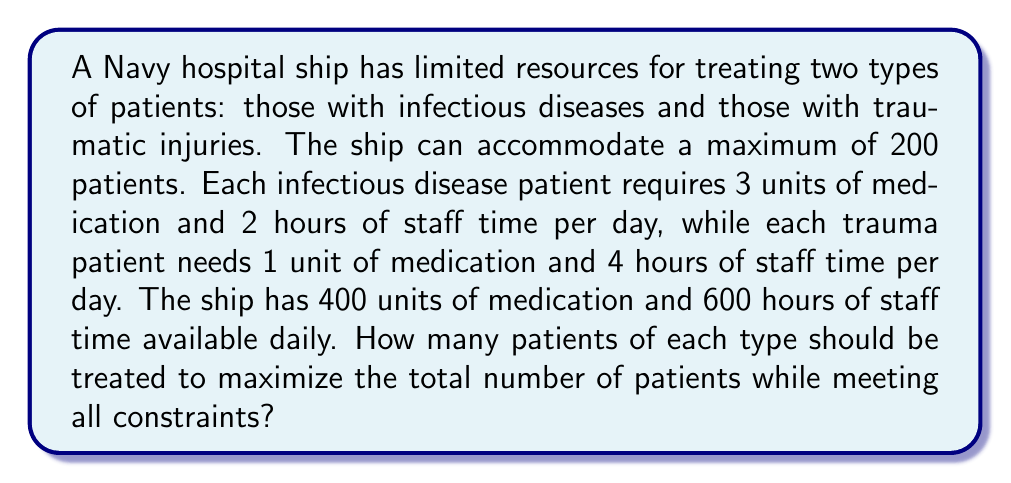Can you answer this question? Let's approach this step-by-step:

1) Define variables:
   Let $x$ = number of infectious disease patients
   Let $y$ = number of trauma patients

2) Set up the system of equations based on the constraints:

   Total patients: $x + y \leq 200$ (1)
   Medication constraint: $3x + y \leq 400$ (2)
   Staff time constraint: $2x + 4y \leq 600$ (3)

3) Our objective is to maximize $x + y$, subject to these constraints.

4) Graph the inequalities:
   
   [asy]
   import graph;
   size(200);
   xaxis("x", 0, 200);
   yaxis("y", 0, 200);
   draw((0,200)--(200,0), blue);
   draw((0,400)--(133.33,0), red);
   draw((0,150)--(300,0), green);
   label("(1)", (100,100), blue);
   label("(2)", (66,133), red);
   label("(3)", (150,75), green);
   dot((100,100));
   label("(100,100)", (105,105));
   [/asy]

5) The feasible region is the area bounded by these lines. The optimal solution will be at one of the intersection points of these lines.

6) Solve for the intersection points:
   
   (1) and (2): $x + y = 200$ and $3x + y = 400$
   Subtracting: $2x = 200$, so $x = 100$, $y = 100$

   (2) and (3): $3x + y = 400$ and $2x + 4y = 600$
   Multiplying (2) by 2 and subtracting: $4x - 8y = 200$
   $x - 2y = 50$
   $x = 2y + 50$
   Substituting into (2): $3(2y + 50) + y = 400$
   $6y + 150 + y = 400$
   $7y = 250$
   $y \approx 35.71$, $x \approx 121.43$

   (1) and (3): $x + y = 200$ and $2x + 4y = 600$
   Substituting $y = 200 - x$ into (3):
   $2x + 4(200 - x) = 600$
   $2x + 800 - 4x = 600$
   $-2x = -200$
   $x = 100$, $y = 100$

7) The point (100, 100) appears twice and gives the maximum total of 200 patients, which also satisfies all constraints.
Answer: 100 infectious disease patients and 100 trauma patients 